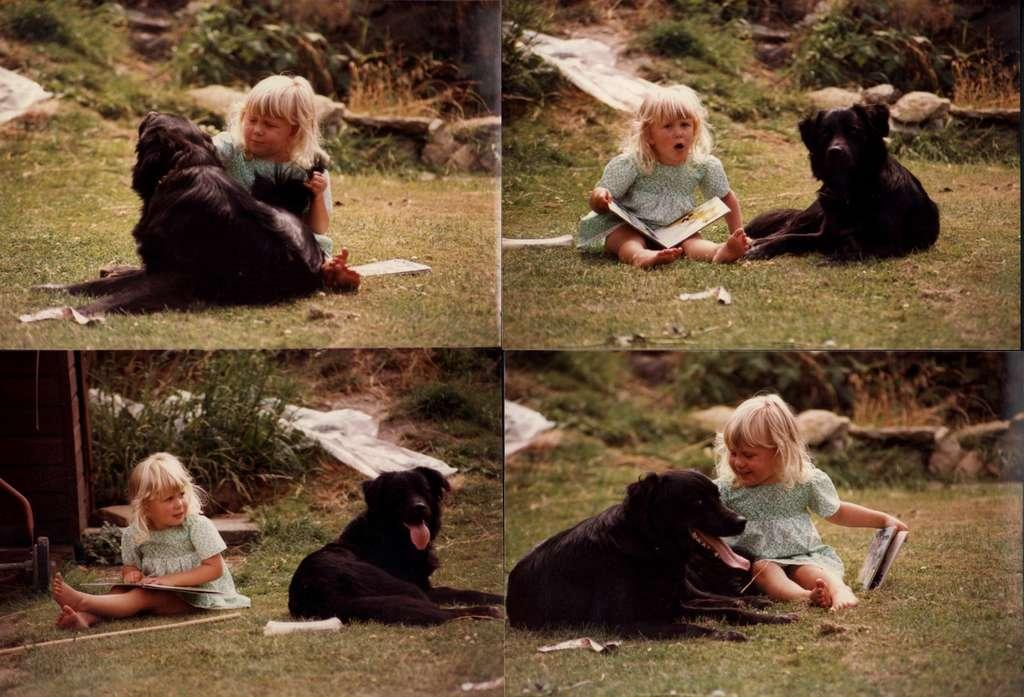Who is the main subject in the image? There is a girl in the image. What is the girl holding in the image? The girl is holding a book. Are there any animals present in the image? Yes, there is a dog in the image. Where is the dog located in the image? The dog is sitting in the garden. How many times has the dog folded the hydrant in the image? There is no hydrant present in the image, and dogs do not have the ability to fold objects. 